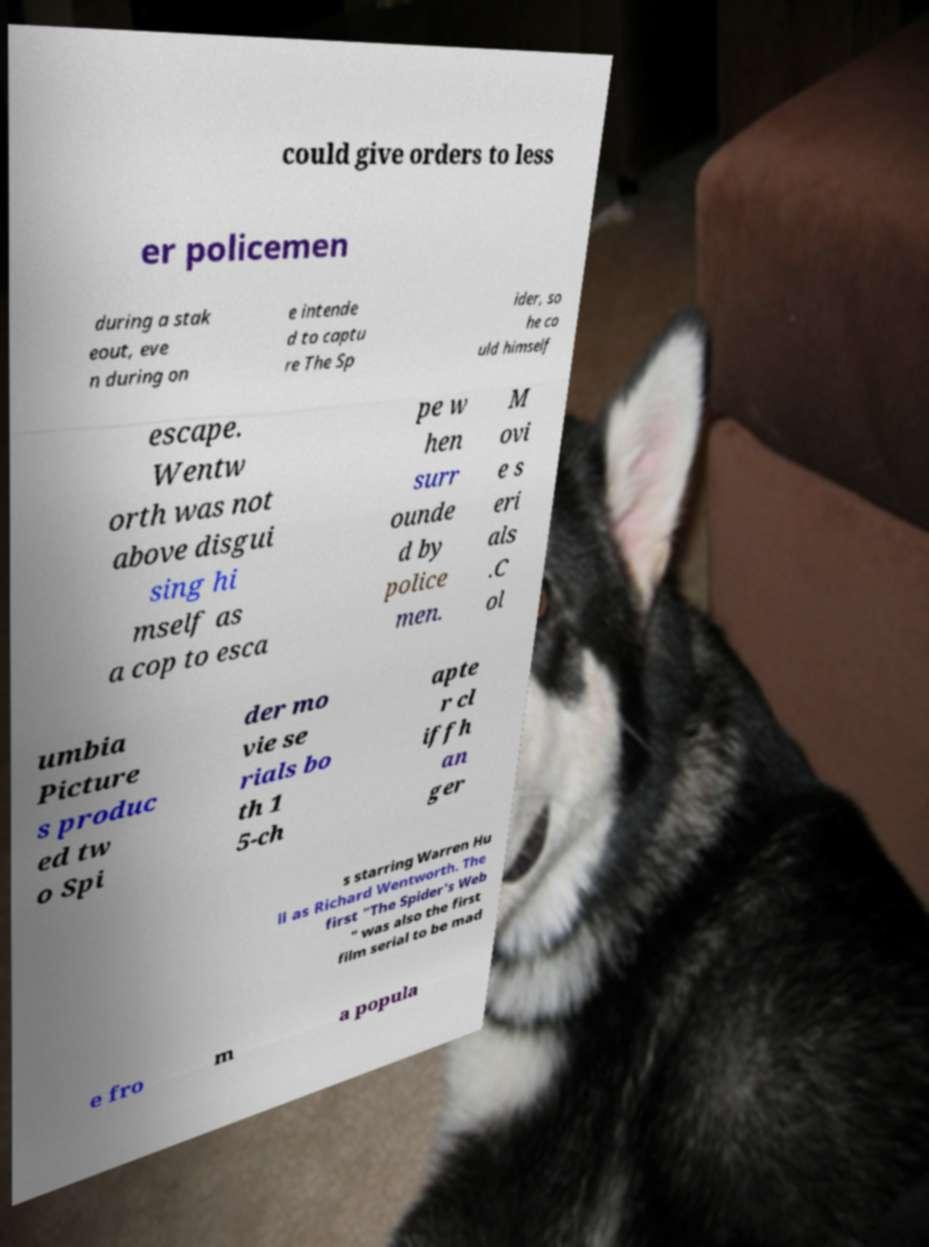There's text embedded in this image that I need extracted. Can you transcribe it verbatim? could give orders to less er policemen during a stak eout, eve n during on e intende d to captu re The Sp ider, so he co uld himself escape. Wentw orth was not above disgui sing hi mself as a cop to esca pe w hen surr ounde d by police men. M ovi e s eri als .C ol umbia Picture s produc ed tw o Spi der mo vie se rials bo th 1 5-ch apte r cl iffh an ger s starring Warren Hu ll as Richard Wentworth. The first "The Spider's Web " was also the first film serial to be mad e fro m a popula 